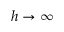<formula> <loc_0><loc_0><loc_500><loc_500>h \rightarrow \infty</formula> 